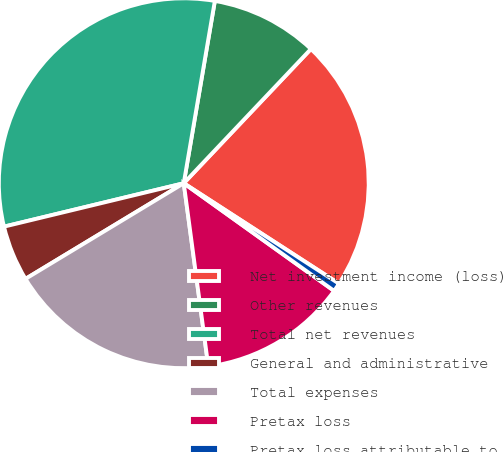Convert chart. <chart><loc_0><loc_0><loc_500><loc_500><pie_chart><fcel>Net investment income (loss)<fcel>Other revenues<fcel>Total net revenues<fcel>General and administrative<fcel>Total expenses<fcel>Pretax loss<fcel>Pretax loss attributable to<nl><fcel>22.07%<fcel>9.38%<fcel>31.46%<fcel>4.88%<fcel>18.47%<fcel>12.99%<fcel>0.75%<nl></chart> 